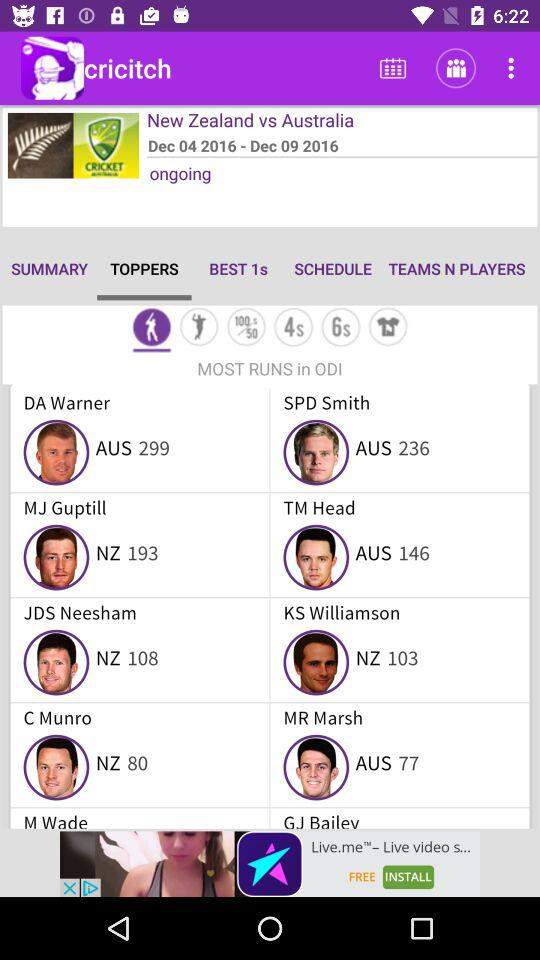How many runs did DA Warner score? DA Warner scored 299 runs. 